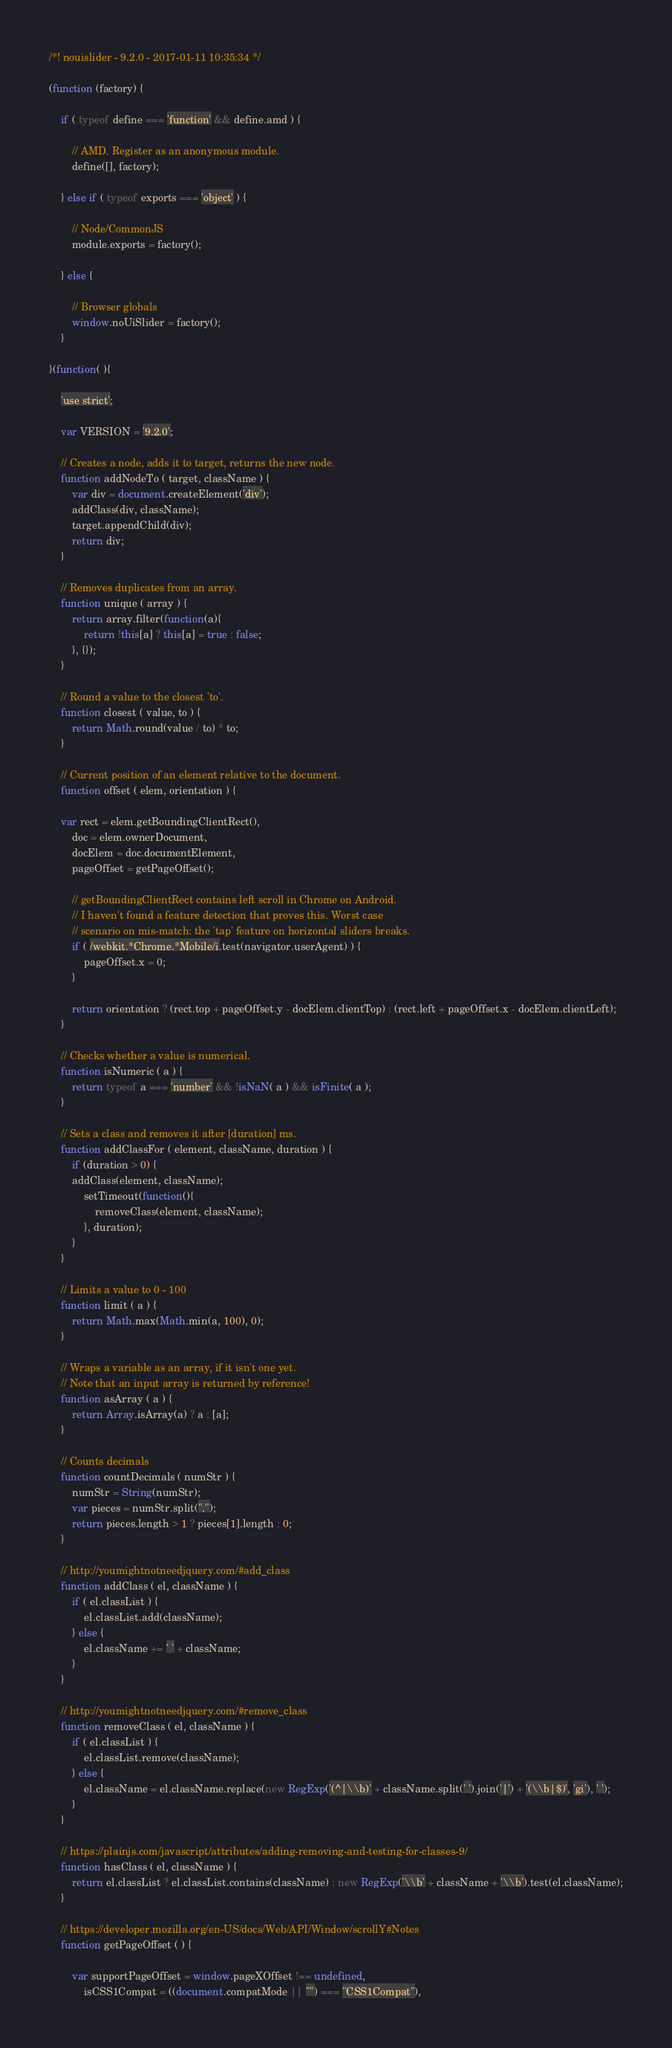<code> <loc_0><loc_0><loc_500><loc_500><_JavaScript_>/*! nouislider - 9.2.0 - 2017-01-11 10:35:34 */

(function (factory) {

    if ( typeof define === 'function' && define.amd ) {

        // AMD. Register as an anonymous module.
        define([], factory);

    } else if ( typeof exports === 'object' ) {

        // Node/CommonJS
        module.exports = factory();

    } else {

        // Browser globals
        window.noUiSlider = factory();
    }

}(function( ){

	'use strict';

	var VERSION = '9.2.0';

	// Creates a node, adds it to target, returns the new node.
	function addNodeTo ( target, className ) {
		var div = document.createElement('div');
		addClass(div, className);
		target.appendChild(div);
		return div;
	}

	// Removes duplicates from an array.
	function unique ( array ) {
		return array.filter(function(a){
			return !this[a] ? this[a] = true : false;
		}, {});
	}

	// Round a value to the closest 'to'.
	function closest ( value, to ) {
		return Math.round(value / to) * to;
	}

	// Current position of an element relative to the document.
	function offset ( elem, orientation ) {

	var rect = elem.getBoundingClientRect(),
		doc = elem.ownerDocument,
		docElem = doc.documentElement,
		pageOffset = getPageOffset();

		// getBoundingClientRect contains left scroll in Chrome on Android.
		// I haven't found a feature detection that proves this. Worst case
		// scenario on mis-match: the 'tap' feature on horizontal sliders breaks.
		if ( /webkit.*Chrome.*Mobile/i.test(navigator.userAgent) ) {
			pageOffset.x = 0;
		}

		return orientation ? (rect.top + pageOffset.y - docElem.clientTop) : (rect.left + pageOffset.x - docElem.clientLeft);
	}

	// Checks whether a value is numerical.
	function isNumeric ( a ) {
		return typeof a === 'number' && !isNaN( a ) && isFinite( a );
	}

	// Sets a class and removes it after [duration] ms.
	function addClassFor ( element, className, duration ) {
		if (duration > 0) {
		addClass(element, className);
			setTimeout(function(){
				removeClass(element, className);
			}, duration);
		}
	}

	// Limits a value to 0 - 100
	function limit ( a ) {
		return Math.max(Math.min(a, 100), 0);
	}

	// Wraps a variable as an array, if it isn't one yet.
	// Note that an input array is returned by reference!
	function asArray ( a ) {
		return Array.isArray(a) ? a : [a];
	}

	// Counts decimals
	function countDecimals ( numStr ) {
		numStr = String(numStr);
		var pieces = numStr.split(".");
		return pieces.length > 1 ? pieces[1].length : 0;
	}

	// http://youmightnotneedjquery.com/#add_class
	function addClass ( el, className ) {
		if ( el.classList ) {
			el.classList.add(className);
		} else {
			el.className += ' ' + className;
		}
	}

	// http://youmightnotneedjquery.com/#remove_class
	function removeClass ( el, className ) {
		if ( el.classList ) {
			el.classList.remove(className);
		} else {
			el.className = el.className.replace(new RegExp('(^|\\b)' + className.split(' ').join('|') + '(\\b|$)', 'gi'), ' ');
		}
	}

	// https://plainjs.com/javascript/attributes/adding-removing-and-testing-for-classes-9/
	function hasClass ( el, className ) {
		return el.classList ? el.classList.contains(className) : new RegExp('\\b' + className + '\\b').test(el.className);
	}

	// https://developer.mozilla.org/en-US/docs/Web/API/Window/scrollY#Notes
	function getPageOffset ( ) {

		var supportPageOffset = window.pageXOffset !== undefined,
			isCSS1Compat = ((document.compatMode || "") === "CSS1Compat"),</code> 